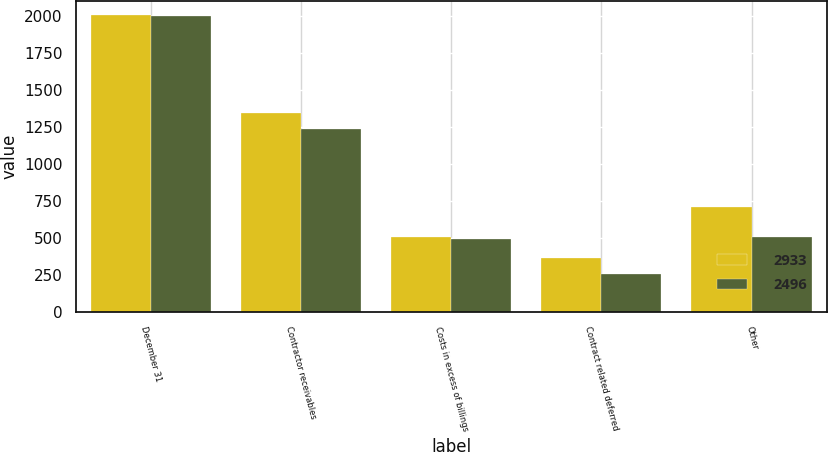Convert chart to OTSL. <chart><loc_0><loc_0><loc_500><loc_500><stacked_bar_chart><ecel><fcel>December 31<fcel>Contractor receivables<fcel>Costs in excess of billings<fcel>Contract related deferred<fcel>Other<nl><fcel>2933<fcel>2006<fcel>1349<fcel>505<fcel>369<fcel>710<nl><fcel>2496<fcel>2005<fcel>1240<fcel>495<fcel>255<fcel>506<nl></chart> 